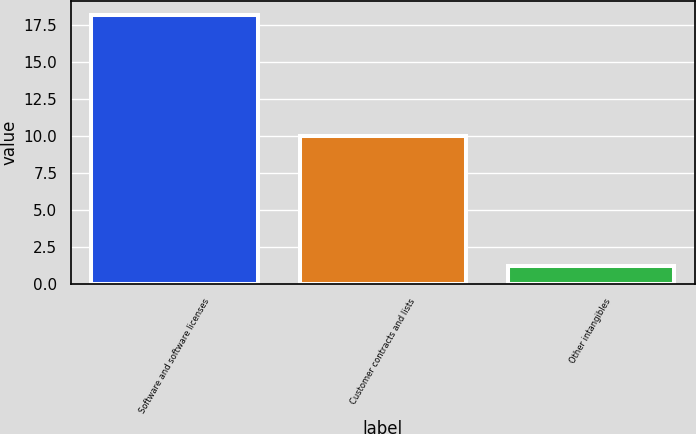Convert chart to OTSL. <chart><loc_0><loc_0><loc_500><loc_500><bar_chart><fcel>Software and software licenses<fcel>Customer contracts and lists<fcel>Other intangibles<nl><fcel>18.2<fcel>10<fcel>1.2<nl></chart> 